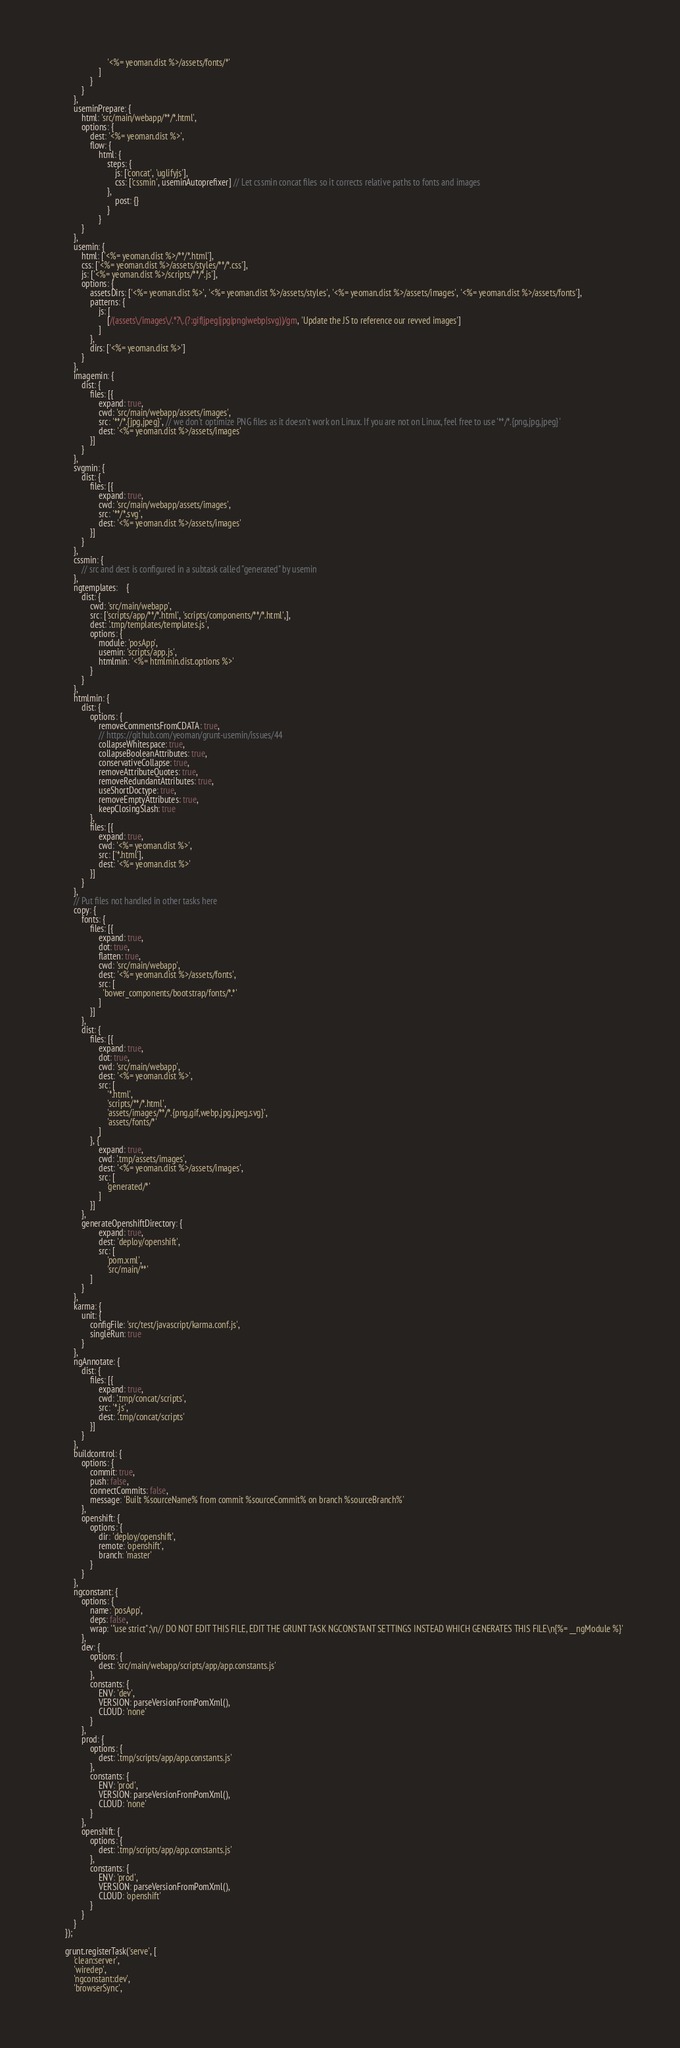Convert code to text. <code><loc_0><loc_0><loc_500><loc_500><_JavaScript_>                        '<%= yeoman.dist %>/assets/fonts/*'
                    ]
                }
            }
        },
        useminPrepare: {
            html: 'src/main/webapp/**/*.html',
            options: {
                dest: '<%= yeoman.dist %>',
                flow: {
                    html: {
                        steps: {
                            js: ['concat', 'uglifyjs'],
                            css: ['cssmin', useminAutoprefixer] // Let cssmin concat files so it corrects relative paths to fonts and images
                        },
                            post: {}
                        }
                    }
            }
        },
        usemin: {
            html: ['<%= yeoman.dist %>/**/*.html'],
            css: ['<%= yeoman.dist %>/assets/styles/**/*.css'],
            js: ['<%= yeoman.dist %>/scripts/**/*.js'],
            options: {
                assetsDirs: ['<%= yeoman.dist %>', '<%= yeoman.dist %>/assets/styles', '<%= yeoman.dist %>/assets/images', '<%= yeoman.dist %>/assets/fonts'],
                patterns: {
                    js: [
                        [/(assets\/images\/.*?\.(?:gif|jpeg|jpg|png|webp|svg))/gm, 'Update the JS to reference our revved images']
                    ]
                },
                dirs: ['<%= yeoman.dist %>']
            }
        },
        imagemin: {
            dist: {
                files: [{
                    expand: true,
                    cwd: 'src/main/webapp/assets/images',
                    src: '**/*.{jpg,jpeg}', // we don't optimize PNG files as it doesn't work on Linux. If you are not on Linux, feel free to use '**/*.{png,jpg,jpeg}'
                    dest: '<%= yeoman.dist %>/assets/images'
                }]
            }
        },
        svgmin: {
            dist: {
                files: [{
                    expand: true,
                    cwd: 'src/main/webapp/assets/images',
                    src: '**/*.svg',
                    dest: '<%= yeoman.dist %>/assets/images'
                }]
            }
        },
        cssmin: {
            // src and dest is configured in a subtask called "generated" by usemin
        },
        ngtemplates:    {
            dist: {
                cwd: 'src/main/webapp',
                src: ['scripts/app/**/*.html', 'scripts/components/**/*.html',],
                dest: '.tmp/templates/templates.js',
                options: {
                    module: 'posApp',
                    usemin: 'scripts/app.js',
                    htmlmin: '<%= htmlmin.dist.options %>'
                }
            }
        },
        htmlmin: {
            dist: {
                options: {
                    removeCommentsFromCDATA: true,
                    // https://github.com/yeoman/grunt-usemin/issues/44
                    collapseWhitespace: true,
                    collapseBooleanAttributes: true,
                    conservativeCollapse: true,
                    removeAttributeQuotes: true,
                    removeRedundantAttributes: true,
                    useShortDoctype: true,
                    removeEmptyAttributes: true,
                    keepClosingSlash: true
                },
                files: [{
                    expand: true,
                    cwd: '<%= yeoman.dist %>',
                    src: ['*.html'],
                    dest: '<%= yeoman.dist %>'
                }]
            }
        },
        // Put files not handled in other tasks here
        copy: {
            fonts: {
                files: [{
                    expand: true,
                    dot: true,
                    flatten: true,
                    cwd: 'src/main/webapp',
                    dest: '<%= yeoman.dist %>/assets/fonts',
                    src: [
                      'bower_components/bootstrap/fonts/*.*'
                    ]
                }]
            },
            dist: {
                files: [{
                    expand: true,
                    dot: true,
                    cwd: 'src/main/webapp',
                    dest: '<%= yeoman.dist %>',
                    src: [
                        '*.html',
                        'scripts/**/*.html',
                        'assets/images/**/*.{png,gif,webp,jpg,jpeg,svg}',
                        'assets/fonts/*'
                    ]
                }, {
                    expand: true,
                    cwd: '.tmp/assets/images',
                    dest: '<%= yeoman.dist %>/assets/images',
                    src: [
                        'generated/*'
                    ]
                }]
            },
            generateOpenshiftDirectory: {
                    expand: true,
                    dest: 'deploy/openshift',
                    src: [
                        'pom.xml',
                        'src/main/**'
                ]
            }
        },
        karma: {
            unit: {
                configFile: 'src/test/javascript/karma.conf.js',
                singleRun: true
            }
        },
        ngAnnotate: {
            dist: {
                files: [{
                    expand: true,
                    cwd: '.tmp/concat/scripts',
                    src: '*.js',
                    dest: '.tmp/concat/scripts'
                }]
            }
        },
        buildcontrol: {
            options: {
                commit: true,
                push: false,
                connectCommits: false,
                message: 'Built %sourceName% from commit %sourceCommit% on branch %sourceBranch%'
            },
            openshift: {
                options: {
                    dir: 'deploy/openshift',
                    remote: 'openshift',
                    branch: 'master'
                }
            }
        },
        ngconstant: {
            options: {
                name: 'posApp',
                deps: false,
                wrap: '"use strict";\n// DO NOT EDIT THIS FILE, EDIT THE GRUNT TASK NGCONSTANT SETTINGS INSTEAD WHICH GENERATES THIS FILE\n{%= __ngModule %}'
            },
            dev: {
                options: {
                    dest: 'src/main/webapp/scripts/app/app.constants.js'
                },
                constants: {
                    ENV: 'dev',
                    VERSION: parseVersionFromPomXml(),
                    CLOUD: 'none'                
				}
            },
            prod: {
                options: {
                    dest: '.tmp/scripts/app/app.constants.js'
                },
                constants: {
                    ENV: 'prod',
                    VERSION: parseVersionFromPomXml(),
                    CLOUD: 'none'                
				}
            },
            openshift: {
                options: {
                    dest: '.tmp/scripts/app/app.constants.js'
                },
                constants: {
                    ENV: 'prod',
                    VERSION: parseVersionFromPomXml(),
                    CLOUD: 'openshift'
                }
            }
        }
    });

    grunt.registerTask('serve', [
        'clean:server',
        'wiredep',
        'ngconstant:dev',
        'browserSync',</code> 